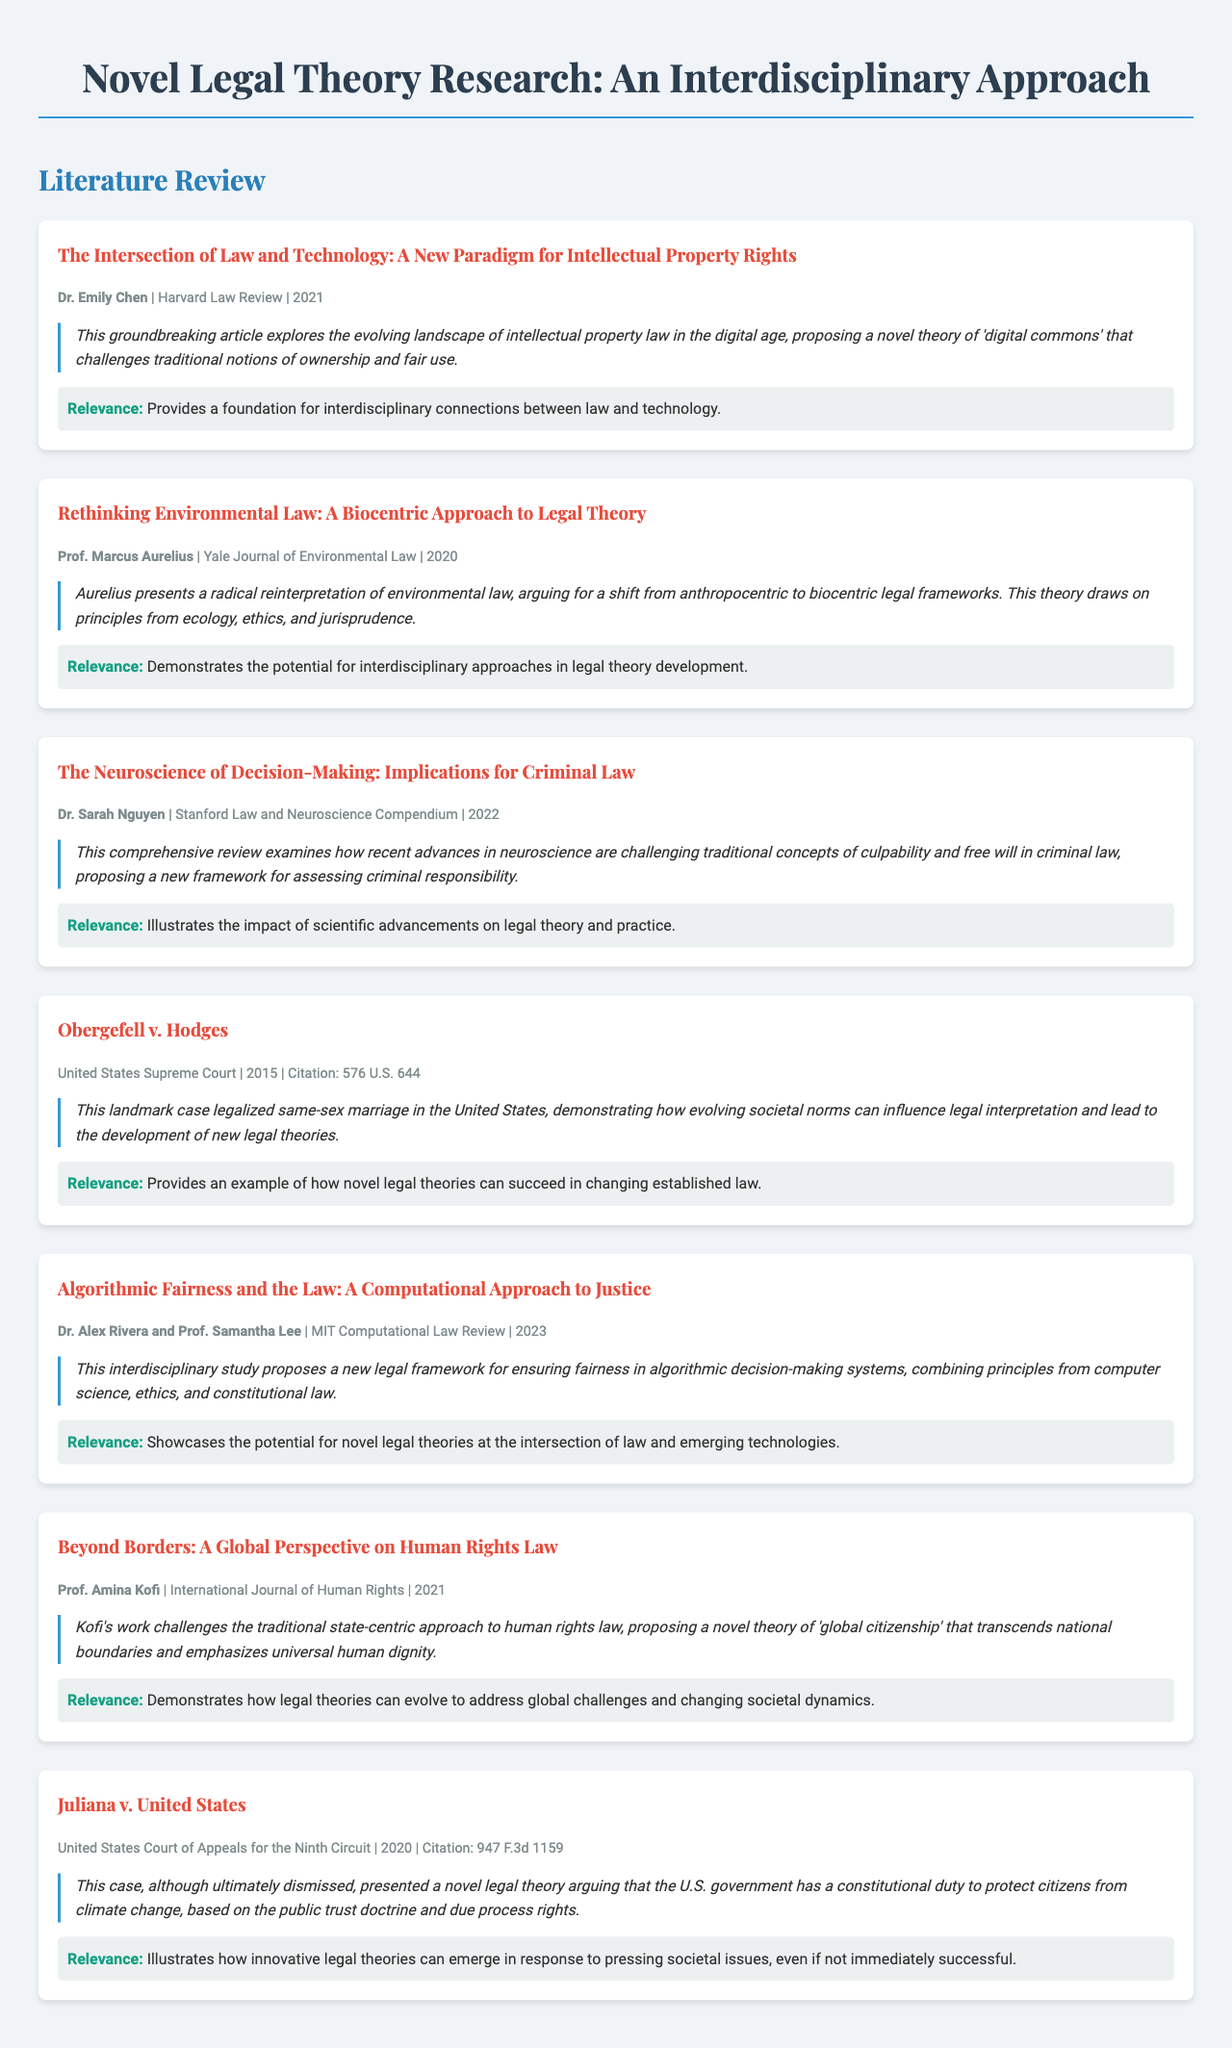what is the title of the article by Dr. Emily Chen? The title is presented as the header of the article section, specifically mentioning the contribution of Dr. Emily Chen.
Answer: The Intersection of Law and Technology: A New Paradigm for Intellectual Property Rights who authored the 2022 publication in the Stanford Law and Neuroscience Compendium? The author's name is provided in the article details, indicating who contributed to this publication.
Answer: Dr. Sarah Nguyen in what year was the case Obergefell v. Hodges decided? The decision year is noted in the case section.
Answer: 2015 what legal framework does the article by Rivera and Lee propose? The framework proposed in the article indicates how the authors combine various disciplines in the legal context.
Answer: A new legal framework for ensuring fairness in algorithmic decision-making systems what is the primary focus of the article by Prof. Amina Kofi? The focus is highlighted in the summary, referring to the main argument of Kofi's work.
Answer: A novel theory of 'global citizenship' how many articles are included in the literature review? The total number of articles listed can be summed from the document's structure, counting each article as it appears.
Answer: 6 which court handled the Juliana v. United States case? The name of the court is provided in the case details, identifying where the case was heard.
Answer: United States Court of Appeals for the Ninth Circuit what concept does Dr. Emily Chen's article challenge? The summary indicates the traditional notions that are being reevaluated in the context of the article.
Answer: Ownership and fair use what year did Prof. Marcus Aurelius publish his article? The publication year is noted alongside the article title and author information.
Answer: 2020 